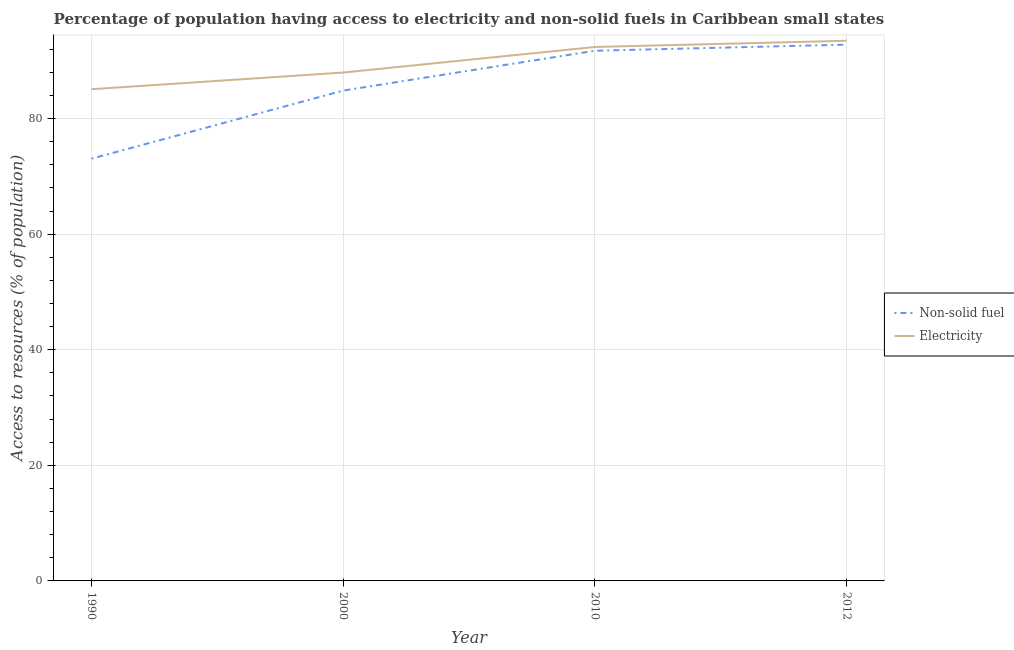How many different coloured lines are there?
Give a very brief answer. 2. Is the number of lines equal to the number of legend labels?
Your answer should be very brief. Yes. What is the percentage of population having access to non-solid fuel in 2000?
Keep it short and to the point. 84.84. Across all years, what is the maximum percentage of population having access to electricity?
Provide a short and direct response. 93.46. Across all years, what is the minimum percentage of population having access to non-solid fuel?
Offer a very short reply. 73.06. In which year was the percentage of population having access to non-solid fuel minimum?
Offer a terse response. 1990. What is the total percentage of population having access to non-solid fuel in the graph?
Your answer should be compact. 342.42. What is the difference between the percentage of population having access to electricity in 1990 and that in 2010?
Keep it short and to the point. -7.31. What is the difference between the percentage of population having access to non-solid fuel in 1990 and the percentage of population having access to electricity in 2012?
Provide a succinct answer. -20.4. What is the average percentage of population having access to electricity per year?
Your answer should be very brief. 89.72. In the year 1990, what is the difference between the percentage of population having access to non-solid fuel and percentage of population having access to electricity?
Your answer should be compact. -12.02. In how many years, is the percentage of population having access to electricity greater than 84 %?
Provide a succinct answer. 4. What is the ratio of the percentage of population having access to electricity in 2000 to that in 2012?
Keep it short and to the point. 0.94. Is the difference between the percentage of population having access to electricity in 2010 and 2012 greater than the difference between the percentage of population having access to non-solid fuel in 2010 and 2012?
Give a very brief answer. No. What is the difference between the highest and the second highest percentage of population having access to electricity?
Your answer should be compact. 1.07. What is the difference between the highest and the lowest percentage of population having access to non-solid fuel?
Your answer should be very brief. 19.73. Does the percentage of population having access to non-solid fuel monotonically increase over the years?
Keep it short and to the point. Yes. Is the percentage of population having access to non-solid fuel strictly less than the percentage of population having access to electricity over the years?
Your answer should be very brief. Yes. How many years are there in the graph?
Give a very brief answer. 4. Are the values on the major ticks of Y-axis written in scientific E-notation?
Your answer should be very brief. No. Does the graph contain any zero values?
Make the answer very short. No. Does the graph contain grids?
Your response must be concise. Yes. Where does the legend appear in the graph?
Provide a short and direct response. Center right. How many legend labels are there?
Offer a terse response. 2. How are the legend labels stacked?
Keep it short and to the point. Vertical. What is the title of the graph?
Provide a short and direct response. Percentage of population having access to electricity and non-solid fuels in Caribbean small states. What is the label or title of the Y-axis?
Your response must be concise. Access to resources (% of population). What is the Access to resources (% of population) in Non-solid fuel in 1990?
Offer a very short reply. 73.06. What is the Access to resources (% of population) of Electricity in 1990?
Ensure brevity in your answer.  85.08. What is the Access to resources (% of population) of Non-solid fuel in 2000?
Provide a succinct answer. 84.84. What is the Access to resources (% of population) in Electricity in 2000?
Make the answer very short. 87.96. What is the Access to resources (% of population) in Non-solid fuel in 2010?
Offer a terse response. 91.73. What is the Access to resources (% of population) in Electricity in 2010?
Offer a very short reply. 92.38. What is the Access to resources (% of population) of Non-solid fuel in 2012?
Your response must be concise. 92.79. What is the Access to resources (% of population) in Electricity in 2012?
Make the answer very short. 93.46. Across all years, what is the maximum Access to resources (% of population) of Non-solid fuel?
Your answer should be compact. 92.79. Across all years, what is the maximum Access to resources (% of population) of Electricity?
Make the answer very short. 93.46. Across all years, what is the minimum Access to resources (% of population) of Non-solid fuel?
Provide a short and direct response. 73.06. Across all years, what is the minimum Access to resources (% of population) in Electricity?
Your response must be concise. 85.08. What is the total Access to resources (% of population) of Non-solid fuel in the graph?
Offer a terse response. 342.42. What is the total Access to resources (% of population) in Electricity in the graph?
Keep it short and to the point. 358.87. What is the difference between the Access to resources (% of population) of Non-solid fuel in 1990 and that in 2000?
Make the answer very short. -11.78. What is the difference between the Access to resources (% of population) in Electricity in 1990 and that in 2000?
Provide a short and direct response. -2.88. What is the difference between the Access to resources (% of population) of Non-solid fuel in 1990 and that in 2010?
Your answer should be compact. -18.68. What is the difference between the Access to resources (% of population) of Electricity in 1990 and that in 2010?
Your answer should be compact. -7.31. What is the difference between the Access to resources (% of population) of Non-solid fuel in 1990 and that in 2012?
Your answer should be very brief. -19.73. What is the difference between the Access to resources (% of population) in Electricity in 1990 and that in 2012?
Keep it short and to the point. -8.38. What is the difference between the Access to resources (% of population) in Non-solid fuel in 2000 and that in 2010?
Ensure brevity in your answer.  -6.89. What is the difference between the Access to resources (% of population) in Electricity in 2000 and that in 2010?
Your answer should be compact. -4.42. What is the difference between the Access to resources (% of population) of Non-solid fuel in 2000 and that in 2012?
Ensure brevity in your answer.  -7.95. What is the difference between the Access to resources (% of population) of Electricity in 2000 and that in 2012?
Keep it short and to the point. -5.5. What is the difference between the Access to resources (% of population) in Non-solid fuel in 2010 and that in 2012?
Your answer should be very brief. -1.05. What is the difference between the Access to resources (% of population) of Electricity in 2010 and that in 2012?
Provide a succinct answer. -1.07. What is the difference between the Access to resources (% of population) in Non-solid fuel in 1990 and the Access to resources (% of population) in Electricity in 2000?
Your answer should be compact. -14.9. What is the difference between the Access to resources (% of population) of Non-solid fuel in 1990 and the Access to resources (% of population) of Electricity in 2010?
Your answer should be very brief. -19.32. What is the difference between the Access to resources (% of population) of Non-solid fuel in 1990 and the Access to resources (% of population) of Electricity in 2012?
Keep it short and to the point. -20.4. What is the difference between the Access to resources (% of population) in Non-solid fuel in 2000 and the Access to resources (% of population) in Electricity in 2010?
Your answer should be very brief. -7.54. What is the difference between the Access to resources (% of population) of Non-solid fuel in 2000 and the Access to resources (% of population) of Electricity in 2012?
Your answer should be compact. -8.62. What is the difference between the Access to resources (% of population) in Non-solid fuel in 2010 and the Access to resources (% of population) in Electricity in 2012?
Provide a short and direct response. -1.72. What is the average Access to resources (% of population) of Non-solid fuel per year?
Provide a succinct answer. 85.6. What is the average Access to resources (% of population) of Electricity per year?
Your response must be concise. 89.72. In the year 1990, what is the difference between the Access to resources (% of population) of Non-solid fuel and Access to resources (% of population) of Electricity?
Provide a short and direct response. -12.02. In the year 2000, what is the difference between the Access to resources (% of population) of Non-solid fuel and Access to resources (% of population) of Electricity?
Provide a short and direct response. -3.12. In the year 2010, what is the difference between the Access to resources (% of population) of Non-solid fuel and Access to resources (% of population) of Electricity?
Give a very brief answer. -0.65. In the year 2012, what is the difference between the Access to resources (% of population) of Non-solid fuel and Access to resources (% of population) of Electricity?
Offer a very short reply. -0.67. What is the ratio of the Access to resources (% of population) of Non-solid fuel in 1990 to that in 2000?
Your answer should be very brief. 0.86. What is the ratio of the Access to resources (% of population) in Electricity in 1990 to that in 2000?
Provide a short and direct response. 0.97. What is the ratio of the Access to resources (% of population) of Non-solid fuel in 1990 to that in 2010?
Your answer should be very brief. 0.8. What is the ratio of the Access to resources (% of population) in Electricity in 1990 to that in 2010?
Provide a succinct answer. 0.92. What is the ratio of the Access to resources (% of population) in Non-solid fuel in 1990 to that in 2012?
Keep it short and to the point. 0.79. What is the ratio of the Access to resources (% of population) of Electricity in 1990 to that in 2012?
Make the answer very short. 0.91. What is the ratio of the Access to resources (% of population) of Non-solid fuel in 2000 to that in 2010?
Provide a succinct answer. 0.92. What is the ratio of the Access to resources (% of population) in Electricity in 2000 to that in 2010?
Your answer should be very brief. 0.95. What is the ratio of the Access to resources (% of population) in Non-solid fuel in 2000 to that in 2012?
Ensure brevity in your answer.  0.91. What is the ratio of the Access to resources (% of population) in Electricity in 2000 to that in 2012?
Your answer should be very brief. 0.94. What is the difference between the highest and the second highest Access to resources (% of population) of Non-solid fuel?
Ensure brevity in your answer.  1.05. What is the difference between the highest and the second highest Access to resources (% of population) in Electricity?
Give a very brief answer. 1.07. What is the difference between the highest and the lowest Access to resources (% of population) of Non-solid fuel?
Make the answer very short. 19.73. What is the difference between the highest and the lowest Access to resources (% of population) of Electricity?
Your answer should be very brief. 8.38. 